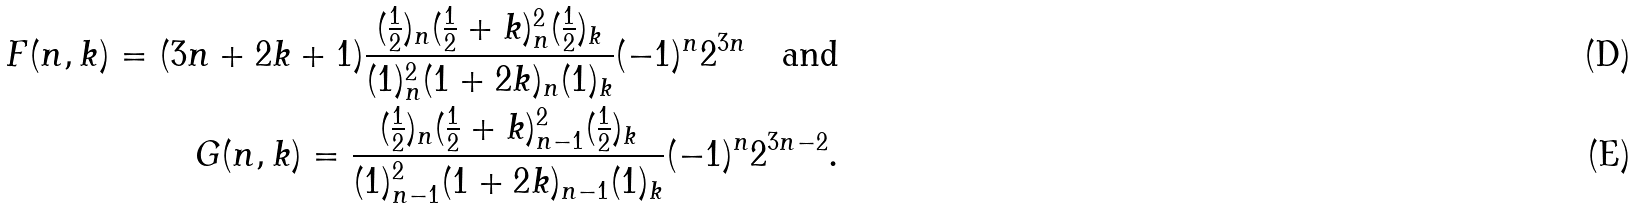<formula> <loc_0><loc_0><loc_500><loc_500>F ( n , k ) = ( 3 n + 2 k + 1 ) \frac { ( \frac { 1 } { 2 } ) _ { n } ( \frac { 1 } { 2 } + k ) _ { n } ^ { 2 } ( \frac { 1 } { 2 } ) _ { k } } { ( 1 ) _ { n } ^ { 2 } ( 1 + 2 k ) _ { n } ( 1 ) _ { k } } ( - 1 ) ^ { n } 2 ^ { 3 n } \quad \text {and} \\ G ( n , k ) = \frac { ( \frac { 1 } { 2 } ) _ { n } ( \frac { 1 } { 2 } + k ) _ { n - 1 } ^ { 2 } ( \frac { 1 } { 2 } ) _ { k } } { ( 1 ) _ { n - 1 } ^ { 2 } ( 1 + 2 k ) _ { n - 1 } ( 1 ) _ { k } } ( - 1 ) ^ { n } 2 ^ { 3 n - 2 } .</formula> 